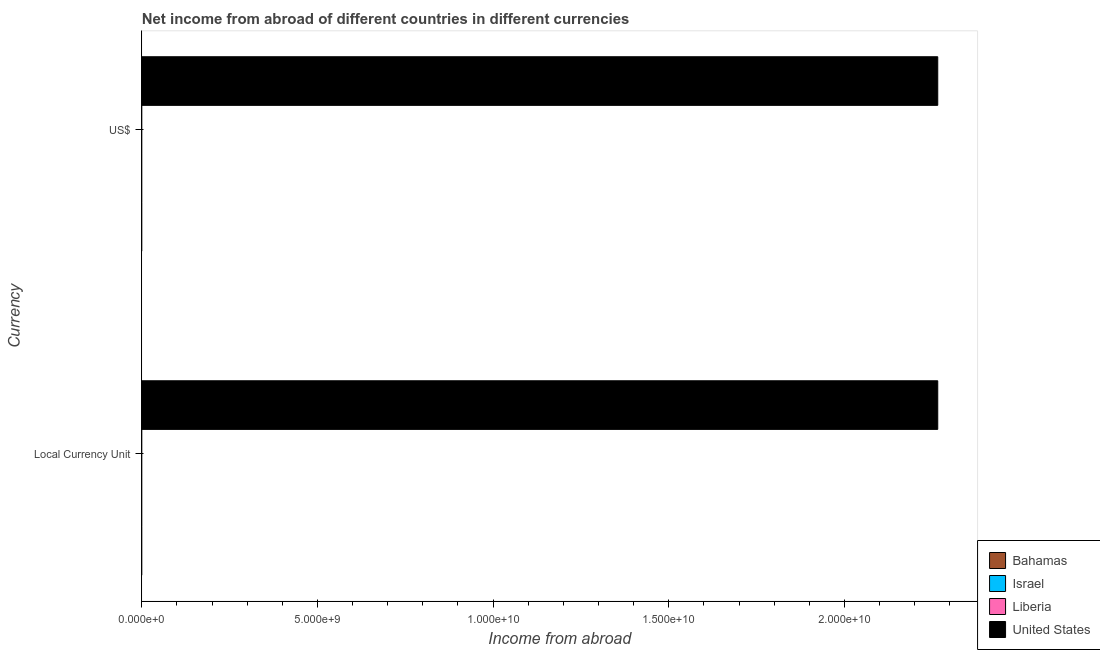How many different coloured bars are there?
Offer a terse response. 1. Are the number of bars per tick equal to the number of legend labels?
Provide a succinct answer. No. Are the number of bars on each tick of the Y-axis equal?
Your answer should be compact. Yes. How many bars are there on the 1st tick from the bottom?
Your answer should be compact. 1. What is the label of the 2nd group of bars from the top?
Give a very brief answer. Local Currency Unit. What is the income from abroad in us$ in Israel?
Make the answer very short. 0. Across all countries, what is the maximum income from abroad in constant 2005 us$?
Offer a terse response. 2.27e+1. Across all countries, what is the minimum income from abroad in us$?
Your response must be concise. 0. What is the total income from abroad in us$ in the graph?
Your response must be concise. 2.27e+1. What is the difference between the income from abroad in us$ in United States and the income from abroad in constant 2005 us$ in Liberia?
Your answer should be very brief. 2.27e+1. What is the average income from abroad in constant 2005 us$ per country?
Your answer should be compact. 5.66e+09. In how many countries, is the income from abroad in constant 2005 us$ greater than the average income from abroad in constant 2005 us$ taken over all countries?
Provide a short and direct response. 1. How many bars are there?
Your answer should be very brief. 2. Does the graph contain any zero values?
Make the answer very short. Yes. Where does the legend appear in the graph?
Make the answer very short. Bottom right. What is the title of the graph?
Ensure brevity in your answer.  Net income from abroad of different countries in different currencies. What is the label or title of the X-axis?
Offer a very short reply. Income from abroad. What is the label or title of the Y-axis?
Keep it short and to the point. Currency. What is the Income from abroad in Israel in Local Currency Unit?
Offer a terse response. 0. What is the Income from abroad in Liberia in Local Currency Unit?
Ensure brevity in your answer.  0. What is the Income from abroad of United States in Local Currency Unit?
Offer a very short reply. 2.27e+1. What is the Income from abroad of Bahamas in US$?
Provide a succinct answer. 0. What is the Income from abroad in Liberia in US$?
Provide a succinct answer. 0. What is the Income from abroad of United States in US$?
Your answer should be very brief. 2.27e+1. Across all Currency, what is the maximum Income from abroad of United States?
Your answer should be compact. 2.27e+1. Across all Currency, what is the minimum Income from abroad in United States?
Give a very brief answer. 2.27e+1. What is the total Income from abroad of United States in the graph?
Make the answer very short. 4.53e+1. What is the difference between the Income from abroad of United States in Local Currency Unit and that in US$?
Provide a succinct answer. 0. What is the average Income from abroad in Bahamas per Currency?
Offer a terse response. 0. What is the average Income from abroad of United States per Currency?
Provide a short and direct response. 2.27e+1. What is the difference between the highest and the lowest Income from abroad of United States?
Provide a short and direct response. 0. 